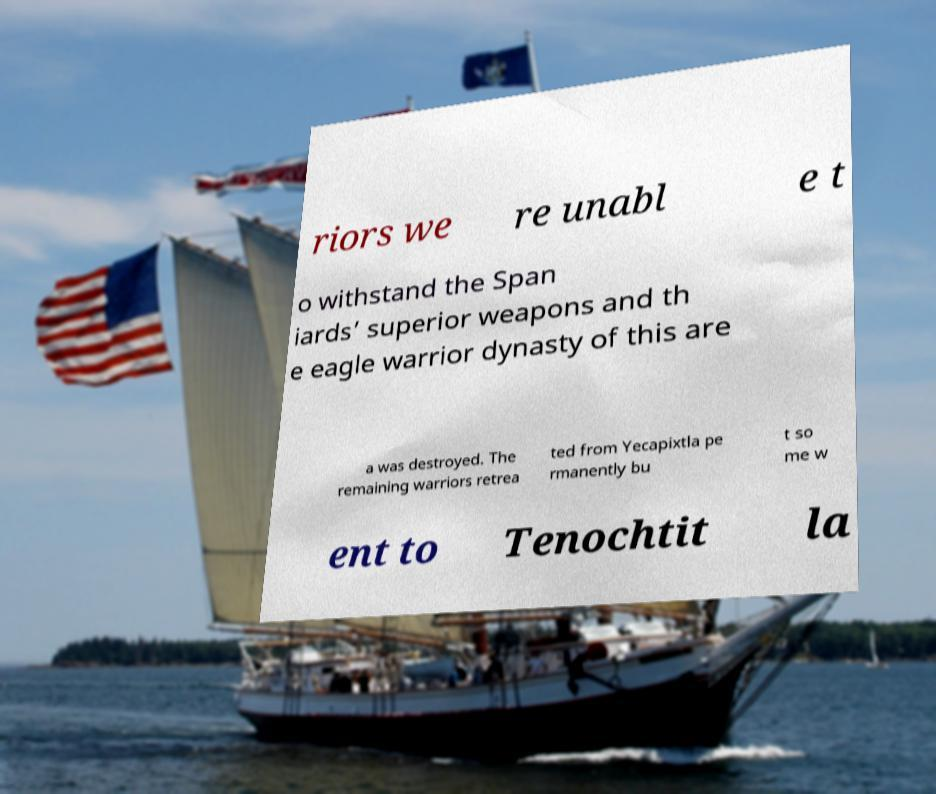Please read and relay the text visible in this image. What does it say? riors we re unabl e t o withstand the Span iards’ superior weapons and th e eagle warrior dynasty of this are a was destroyed. The remaining warriors retrea ted from Yecapixtla pe rmanently bu t so me w ent to Tenochtit la 